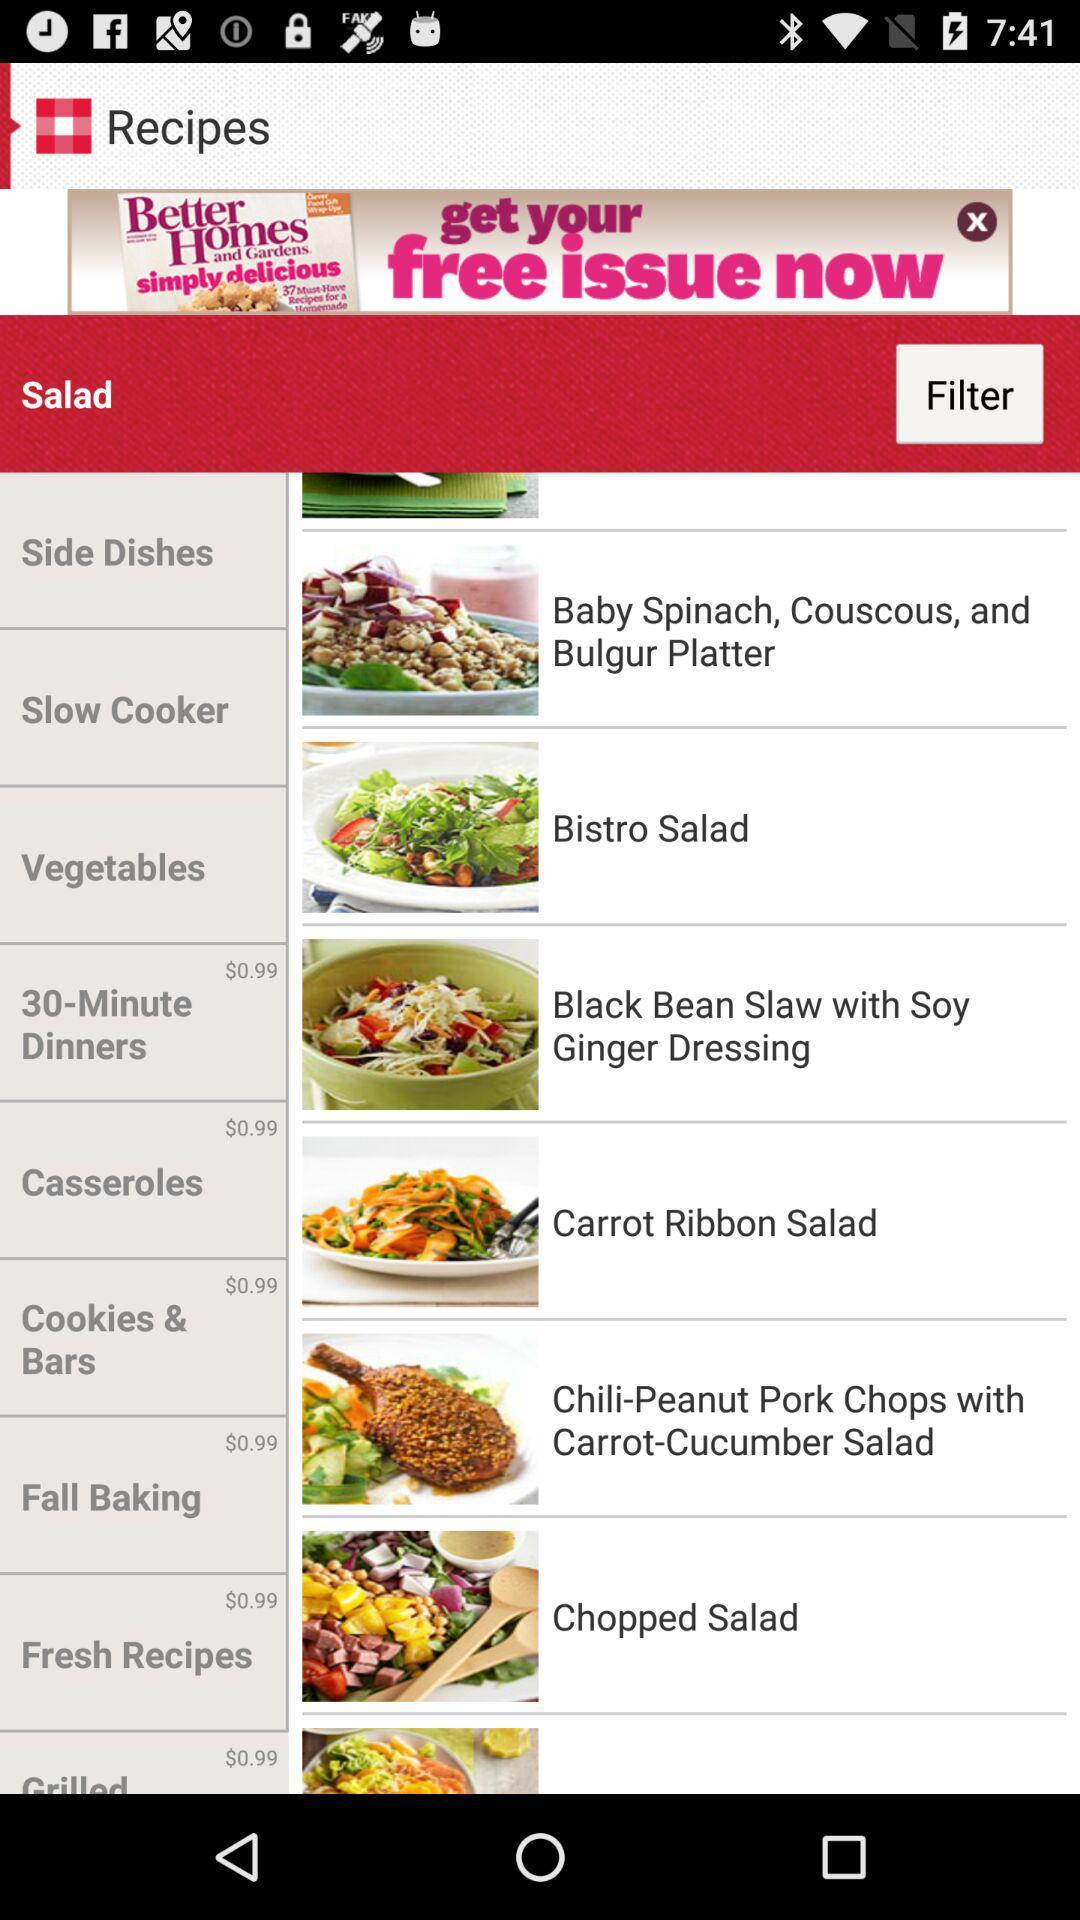What is the price of casseroles? The price is $0.99. 